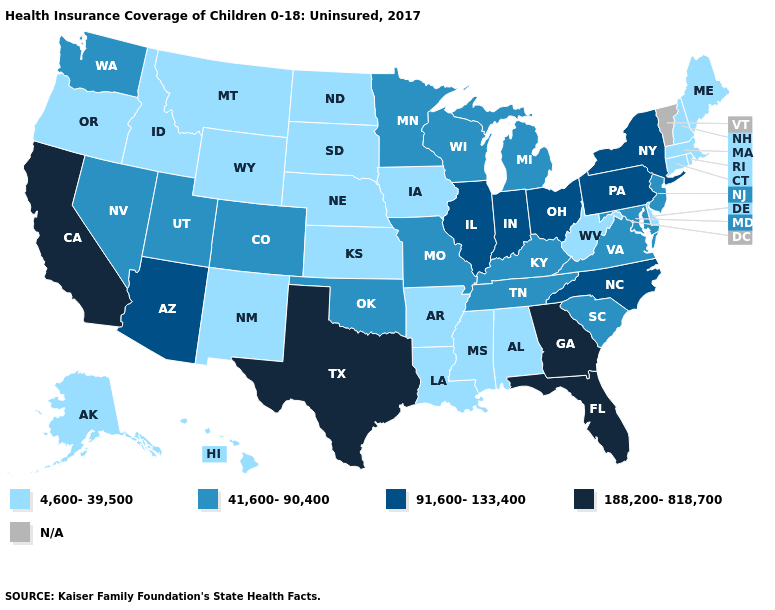Does the map have missing data?
Quick response, please. Yes. What is the highest value in the USA?
Be succinct. 188,200-818,700. Name the states that have a value in the range 41,600-90,400?
Write a very short answer. Colorado, Kentucky, Maryland, Michigan, Minnesota, Missouri, Nevada, New Jersey, Oklahoma, South Carolina, Tennessee, Utah, Virginia, Washington, Wisconsin. Among the states that border New York , does New Jersey have the highest value?
Give a very brief answer. No. What is the value of Tennessee?
Quick response, please. 41,600-90,400. What is the value of Oklahoma?
Keep it brief. 41,600-90,400. What is the lowest value in states that border Michigan?
Quick response, please. 41,600-90,400. What is the value of Maine?
Keep it brief. 4,600-39,500. Does Tennessee have the lowest value in the USA?
Short answer required. No. Among the states that border California , does Arizona have the lowest value?
Quick response, please. No. Name the states that have a value in the range N/A?
Write a very short answer. Vermont. Name the states that have a value in the range N/A?
Quick response, please. Vermont. 